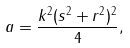Convert formula to latex. <formula><loc_0><loc_0><loc_500><loc_500>a = { \frac { k ^ { 2 } ( s ^ { 2 } + r ^ { 2 } ) ^ { 2 } } { 4 } } ,</formula> 